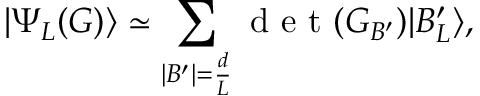<formula> <loc_0><loc_0><loc_500><loc_500>\left | \Psi _ { L } ( G ) \right \rangle \simeq \sum _ { | B ^ { \prime } | = \frac { d } { L } } d e t ( G _ { B ^ { \prime } } ) | B _ { L } ^ { \prime } \rangle ,</formula> 